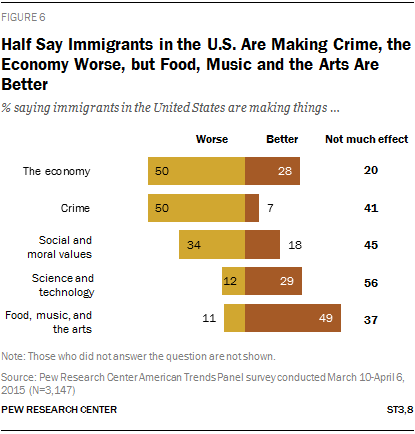Mention a couple of crucial points in this snapshot. Could you please provide the sum of the two largest yellow bars? According to the survey results, a significant majority of respondents, at 28%, believe that immigrants in the United States are positively impacting the economy. 